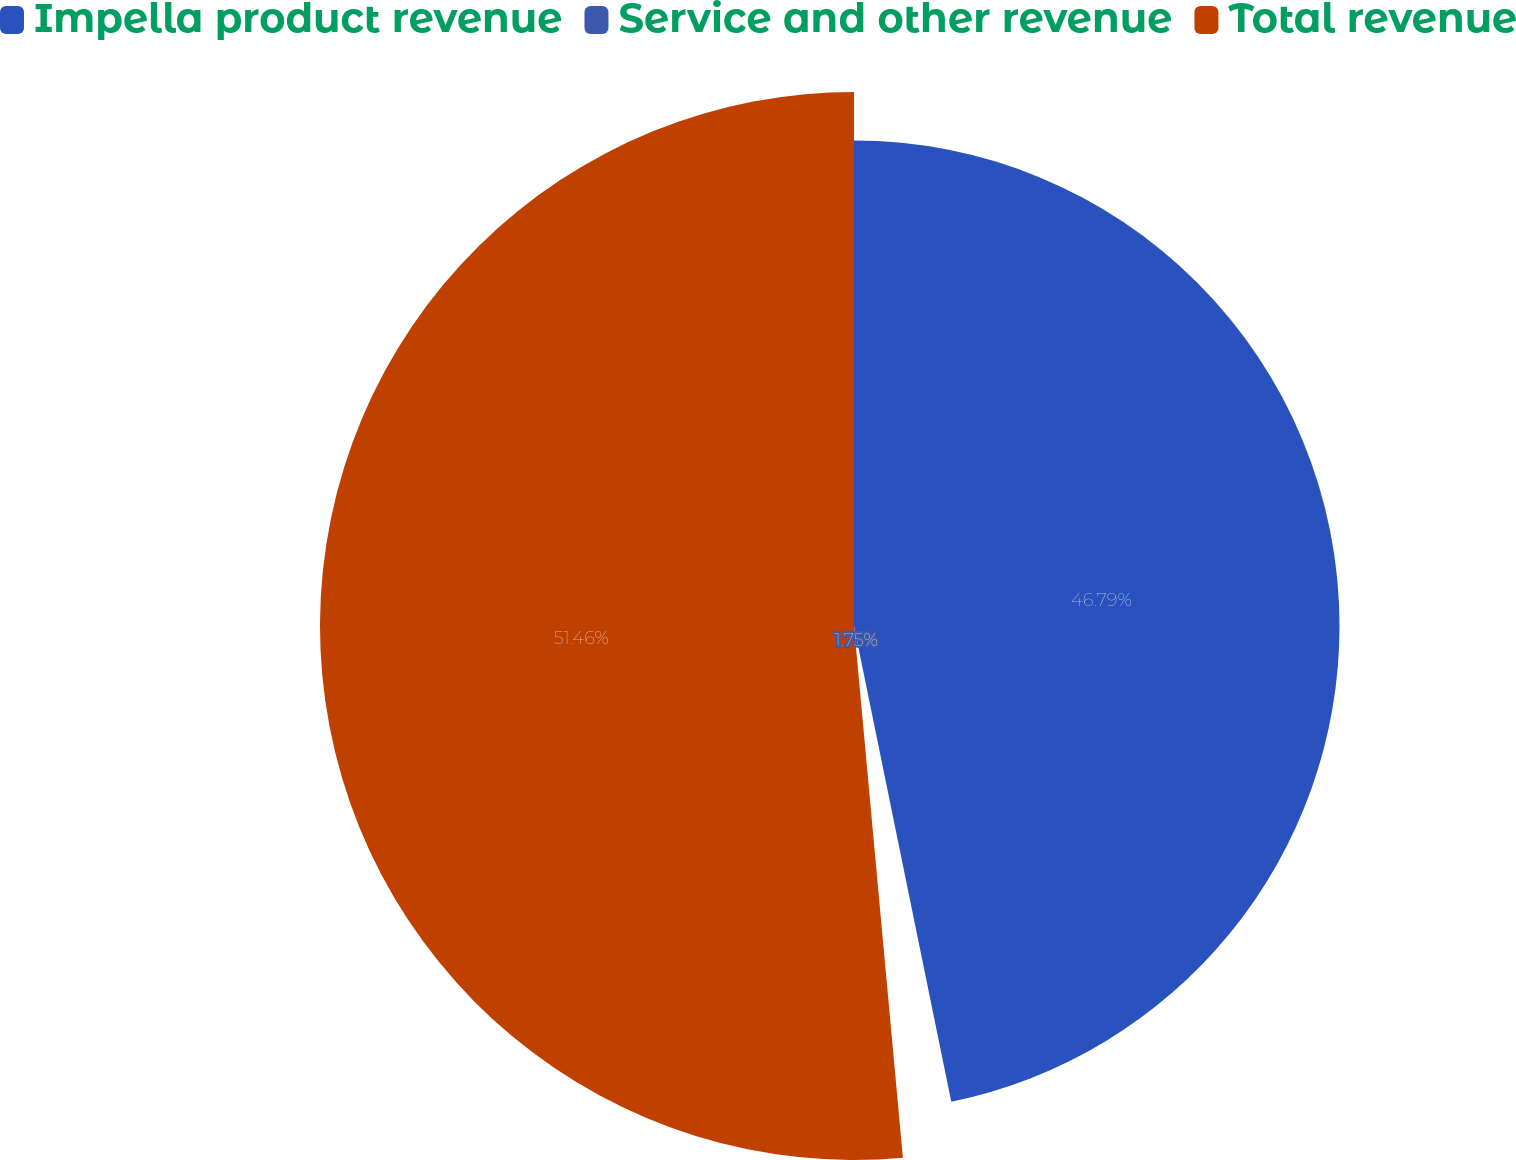<chart> <loc_0><loc_0><loc_500><loc_500><pie_chart><fcel>Impella product revenue<fcel>Service and other revenue<fcel>Total revenue<nl><fcel>46.79%<fcel>1.75%<fcel>51.46%<nl></chart> 